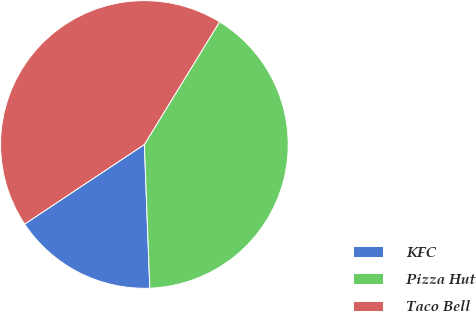<chart> <loc_0><loc_0><loc_500><loc_500><pie_chart><fcel>KFC<fcel>Pizza Hut<fcel>Taco Bell<nl><fcel>16.26%<fcel>40.65%<fcel>43.09%<nl></chart> 